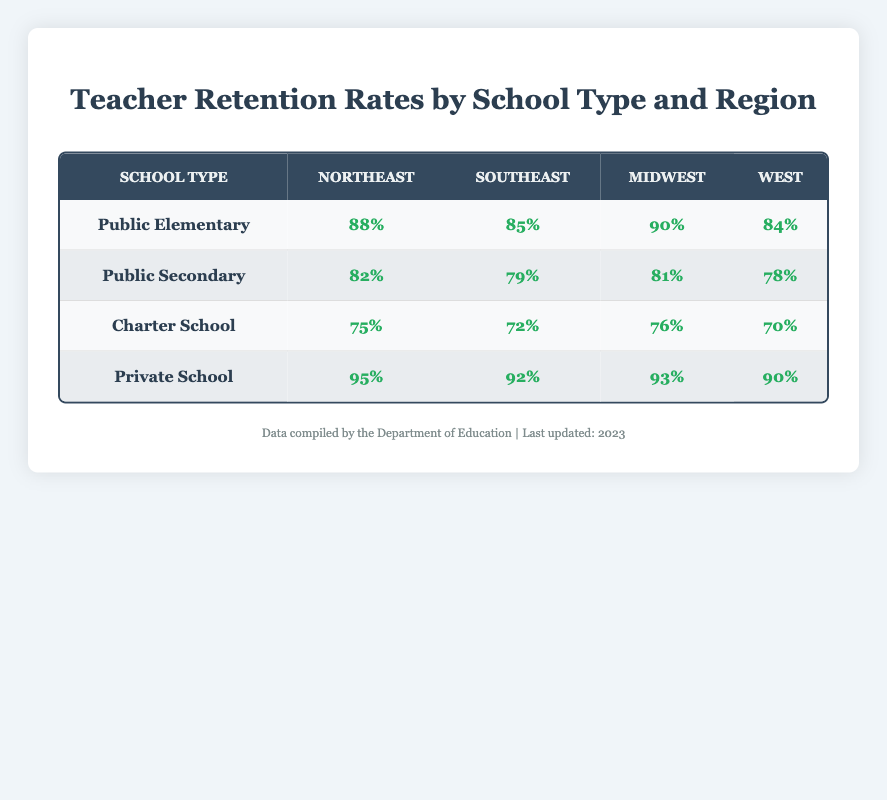What is the retention rate for Private Schools in the Southeast? The table shows that the retention rate for Private Schools in the Southeast region is 92%.
Answer: 92% Which school type has the highest retention rate in the Northeast? In the Northeast region, Private Schools have the highest retention rate at 95%.
Answer: 95% What is the average retention rate for Charter Schools across all regions? The retention rates for Charter Schools are 75%, 72%, 76%, and 70% across the Northeast, Southeast, Midwest, and West, respectively. The total is 75 + 72 + 76 + 70 = 293, and there are 4 regions, so the average is 293/4 = 73.25%.
Answer: 73.25% Is the retention rate for Public Secondary Schools higher than for Charter Schools in any region? By comparing the retention rates, in the Northeast, Public Secondary (82%) is higher than Charter Schools (75%). In the Southeast, Public Secondary (79%) is higher than Charter Schools (72%). In the Midwest, Public Secondary (81%) is higher than Charter Schools (76%). In the West, Public Secondary (78%) is also higher than Charter Schools (70%). Therefore, Public Secondary Schools have higher retention rates in all regions.
Answer: Yes What is the difference in retention rates between Public Elementary Schools and Private Schools in the Midwest? For Public Elementary Schools, the retention rate in the Midwest is 90%, and for Private Schools, it is 93%. The difference is 93 - 90 = 3%.
Answer: 3% How do the retention rates of Public Secondary Schools compare to those of Private Schools across all regions? The retention rates for Public Secondary Schools are 82%, 79%, 81%, and 78% across the Northeast, Southeast, Midwest, and West, respectively. The retention rates for Private Schools are higher in all regions: 95%, 92%, 93%, and 90%, respectively, indicating that Private Schools consistently have higher retention rates compared to Public Secondary Schools.
Answer: Private Schools are consistently higher What is the lowest retention rate recorded for any school type across all regions? Scanning the table, the lowest retention rate is for Charter Schools in the West at 70%.
Answer: 70% What is the total retention rate for Public Elementary Schools across all regions? The retention rates for Public Elementary Schools are 88%, 85%, 90%, and 84% across the Northeast, Southeast, Midwest, and West. The total is 88 + 85 + 90 + 84 = 347.
Answer: 347 Which region has the lowest average retention rates among all school types? To find the region with the lowest average retention rates, we need to calculate the average for each region. Northeast: (88 + 82 + 75 + 95) / 4 = 85. Public Southeast: (85 + 79 + 72 + 92) / 4 = 82. Private Midwest: (90 + 81 + 76 + 93) / 4 = 85. West: (84 + 78 + 70 + 90) / 4 = 80. The West region has the lowest average retention rate of 80%.
Answer: West 